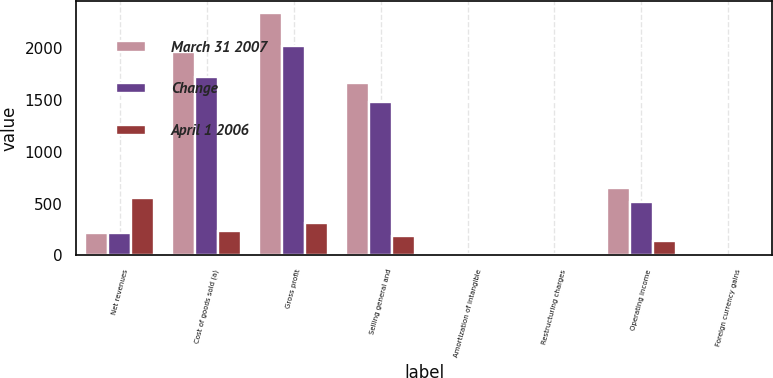Convert chart. <chart><loc_0><loc_0><loc_500><loc_500><stacked_bar_chart><ecel><fcel>Net revenues<fcel>Cost of goods sold (a)<fcel>Gross profit<fcel>Selling general and<fcel>Amortization of intangible<fcel>Restructuring charges<fcel>Operating income<fcel>Foreign currency gains<nl><fcel>March 31 2007<fcel>210.9<fcel>1959.2<fcel>2336.2<fcel>1663.4<fcel>15.6<fcel>4.6<fcel>652.6<fcel>1.5<nl><fcel>Change<fcel>210.9<fcel>1723.9<fcel>2022.4<fcel>1476.9<fcel>9.1<fcel>9<fcel>516.6<fcel>5.7<nl><fcel>April 1 2006<fcel>549.1<fcel>235.3<fcel>313.8<fcel>186.5<fcel>6.5<fcel>4.4<fcel>136<fcel>4.2<nl></chart> 